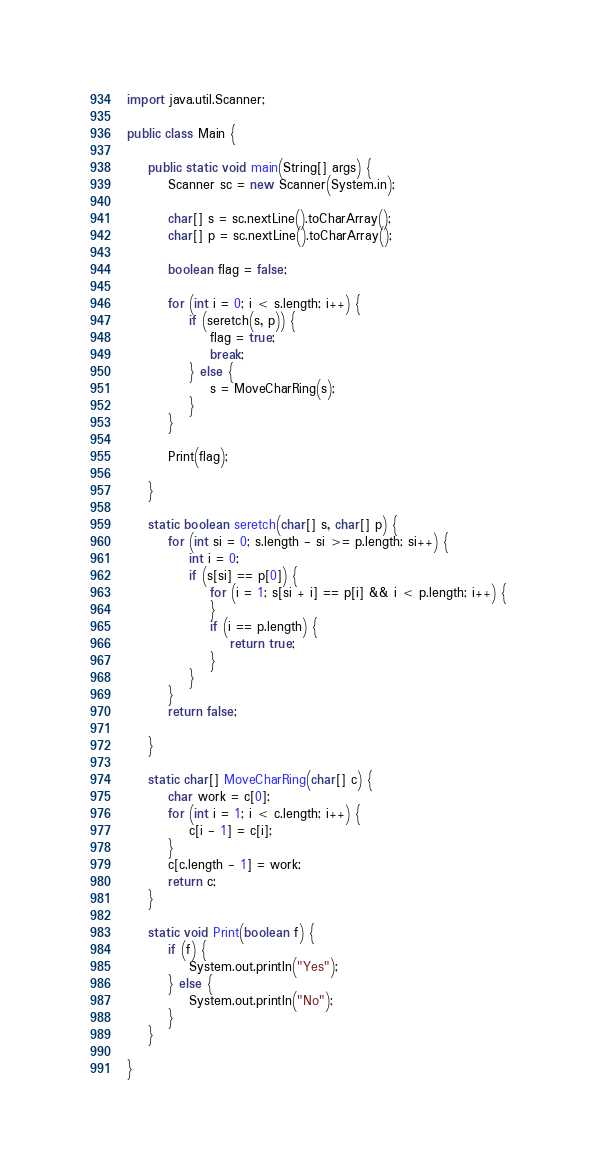Convert code to text. <code><loc_0><loc_0><loc_500><loc_500><_Java_>import java.util.Scanner;

public class Main {

	public static void main(String[] args) {
		Scanner sc = new Scanner(System.in);

		char[] s = sc.nextLine().toCharArray();
		char[] p = sc.nextLine().toCharArray();

		boolean flag = false;

		for (int i = 0; i < s.length; i++) {
			if (seretch(s, p)) {
				flag = true;
				break;
			} else {
				s = MoveCharRing(s);
			}
		}

		Print(flag);

	}

	static boolean seretch(char[] s, char[] p) {
		for (int si = 0; s.length - si >= p.length; si++) {
			int i = 0;
			if (s[si] == p[0]) {
				for (i = 1; s[si + i] == p[i] && i < p.length; i++) {
				}
				if (i == p.length) {
					return true;
				}
			}
		}
		return false;

	}

	static char[] MoveCharRing(char[] c) {
		char work = c[0];
		for (int i = 1; i < c.length; i++) {
			c[i - 1] = c[i];
		}
		c[c.length - 1] = work;
		return c;
	}

	static void Print(boolean f) {
		if (f) {
			System.out.println("Yes");
		} else {
			System.out.println("No");
		}
	}

}

</code> 